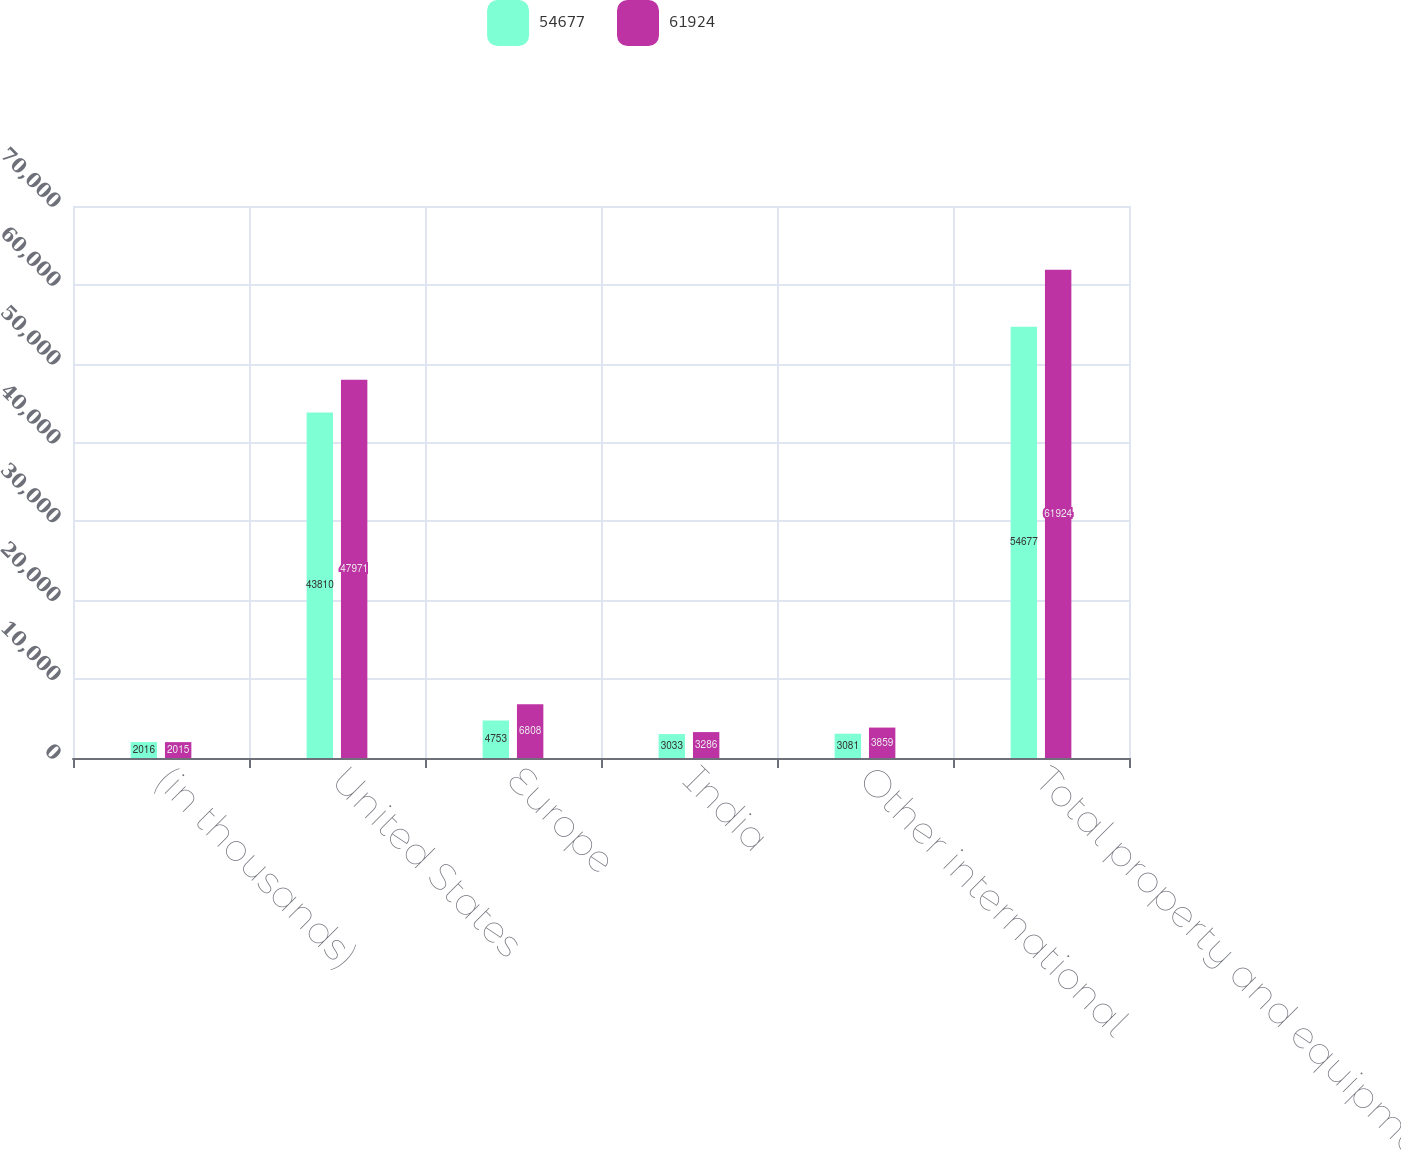Convert chart. <chart><loc_0><loc_0><loc_500><loc_500><stacked_bar_chart><ecel><fcel>(in thousands)<fcel>United States<fcel>Europe<fcel>India<fcel>Other international<fcel>Total property and equipment<nl><fcel>54677<fcel>2016<fcel>43810<fcel>4753<fcel>3033<fcel>3081<fcel>54677<nl><fcel>61924<fcel>2015<fcel>47971<fcel>6808<fcel>3286<fcel>3859<fcel>61924<nl></chart> 